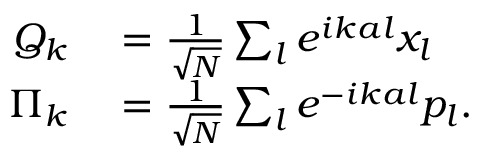Convert formula to latex. <formula><loc_0><loc_0><loc_500><loc_500>\begin{array} { r l } { Q _ { k } } & = { \frac { 1 } { \sqrt { N } } } \sum _ { l } e ^ { i k a l } x _ { l } } \\ { \Pi _ { k } } & = { \frac { 1 } { \sqrt { N } } } \sum _ { l } e ^ { - i k a l } p _ { l } . } \end{array}</formula> 